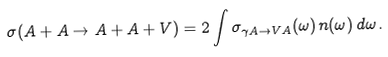Convert formula to latex. <formula><loc_0><loc_0><loc_500><loc_500>\sigma ( A + A \rightarrow A + A + V ) = 2 \int \sigma _ { \gamma A \rightarrow V A } ( \omega ) \, n ( \omega ) \, d \omega \, .</formula> 